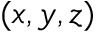Convert formula to latex. <formula><loc_0><loc_0><loc_500><loc_500>( x , y , z )</formula> 